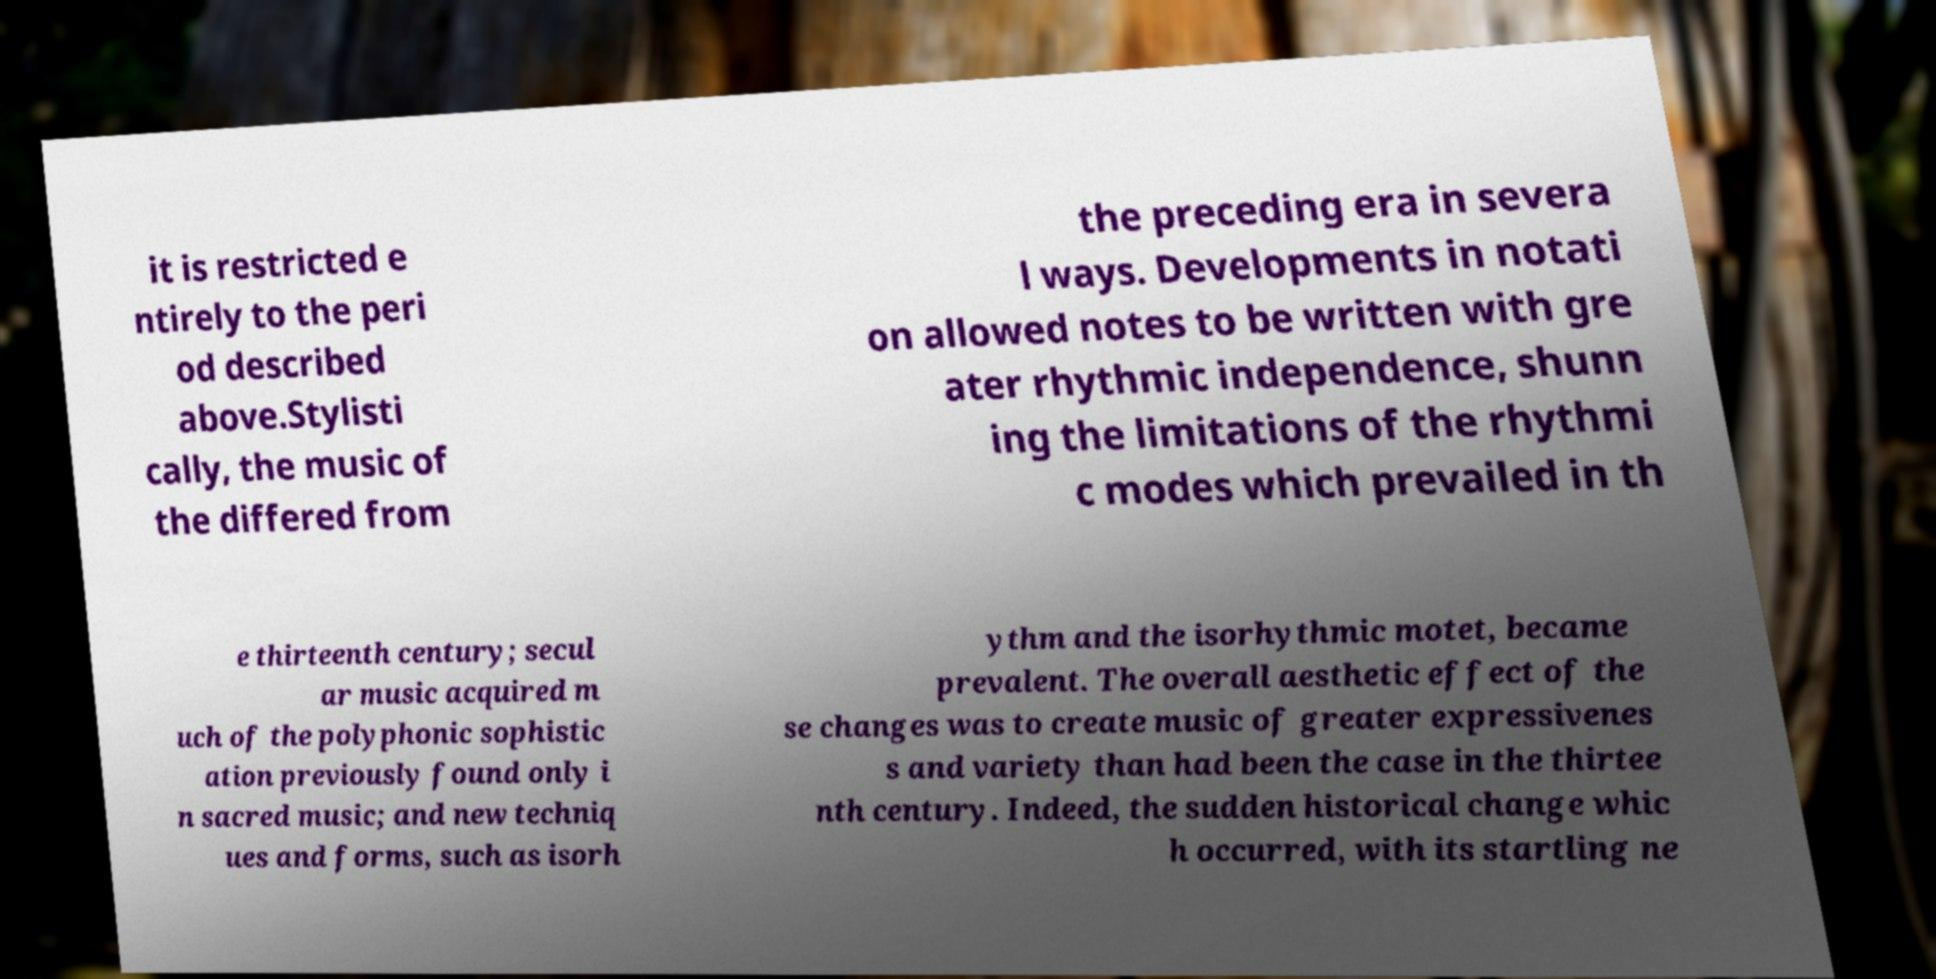I need the written content from this picture converted into text. Can you do that? it is restricted e ntirely to the peri od described above.Stylisti cally, the music of the differed from the preceding era in severa l ways. Developments in notati on allowed notes to be written with gre ater rhythmic independence, shunn ing the limitations of the rhythmi c modes which prevailed in th e thirteenth century; secul ar music acquired m uch of the polyphonic sophistic ation previously found only i n sacred music; and new techniq ues and forms, such as isorh ythm and the isorhythmic motet, became prevalent. The overall aesthetic effect of the se changes was to create music of greater expressivenes s and variety than had been the case in the thirtee nth century. Indeed, the sudden historical change whic h occurred, with its startling ne 